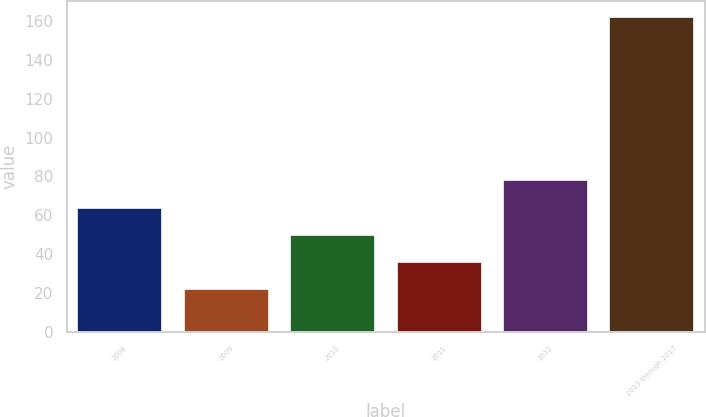Convert chart to OTSL. <chart><loc_0><loc_0><loc_500><loc_500><bar_chart><fcel>2008<fcel>2009<fcel>2010<fcel>2011<fcel>2012<fcel>2013 through 2017<nl><fcel>64<fcel>22<fcel>50<fcel>36<fcel>78<fcel>162<nl></chart> 